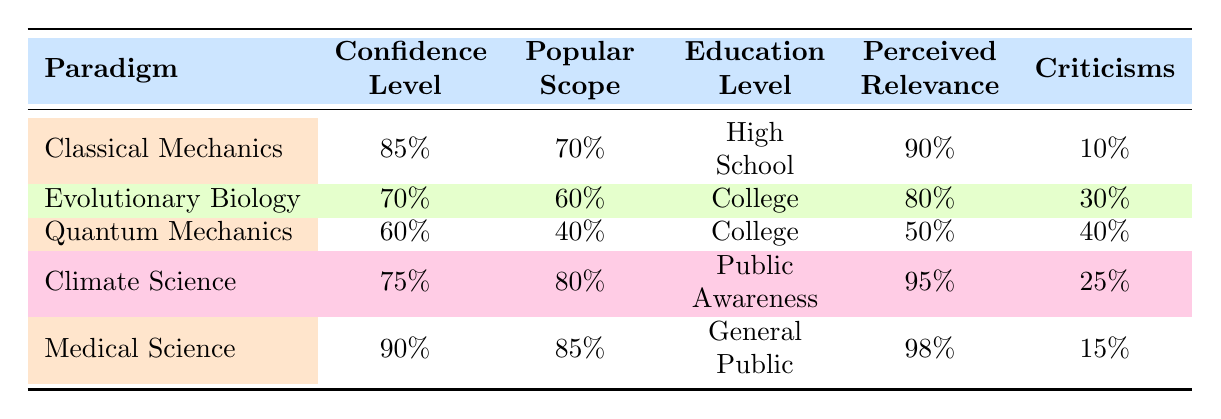What is the confidence level for Medical Science? Referring to Medical Science in the table, its confidence level is listed as 90%.
Answer: 90% What is the perceived relevance of Climate Science? Looking at the row for Climate Science, the perceived relevance is specified as 95%.
Answer: 95% Which scientific paradigm has the highest percentage of criticisms? Examining the "Criticisms" column, Quantum Mechanics has the highest percentage at 40%.
Answer: Quantum Mechanics What is the average confidence level of all scientific paradigms listed? To find the average, sum the confidence levels: (85 + 70 + 60 + 75 + 90) = 380. Then divide by the number of paradigms (5): 380/5 = 76.
Answer: 76 Is the education level for Climate Science higher than that for Evolutionary Biology? Comparing the education levels, Climate Science is labeled as "Public Awareness" while Evolutionary Biology is "College." Since "College" is generally considered higher, the answer is no.
Answer: No Among the paradigms, which one has the lowest popular scope? Reviewing the table, Quantum Mechanics has the lowest popular scope at 40%.
Answer: Quantum Mechanics Is it true that the perceived relevance for Evolutionary Biology is greater than that for Classical Mechanics? Checking the values, Evolutionary Biology has a perceived relevance of 80%, while Classical Mechanics has 90%. Thus, the statement is false.
Answer: No What is the difference between the confidence levels of Classical Mechanics and Quantum Mechanics? The confidence level for Classical Mechanics is 85% and for Quantum Mechanics is 60%. The difference is 85 - 60 = 25.
Answer: 25 Which scientific paradigm has a lower perceived relevance, Quantum Mechanics or Climate Science? Quantum Mechanics has a perceived relevance of 50%, and Climate Science has 95%. Since 50% is less than 95%, the answer is Quantum Mechanics.
Answer: Quantum Mechanics 